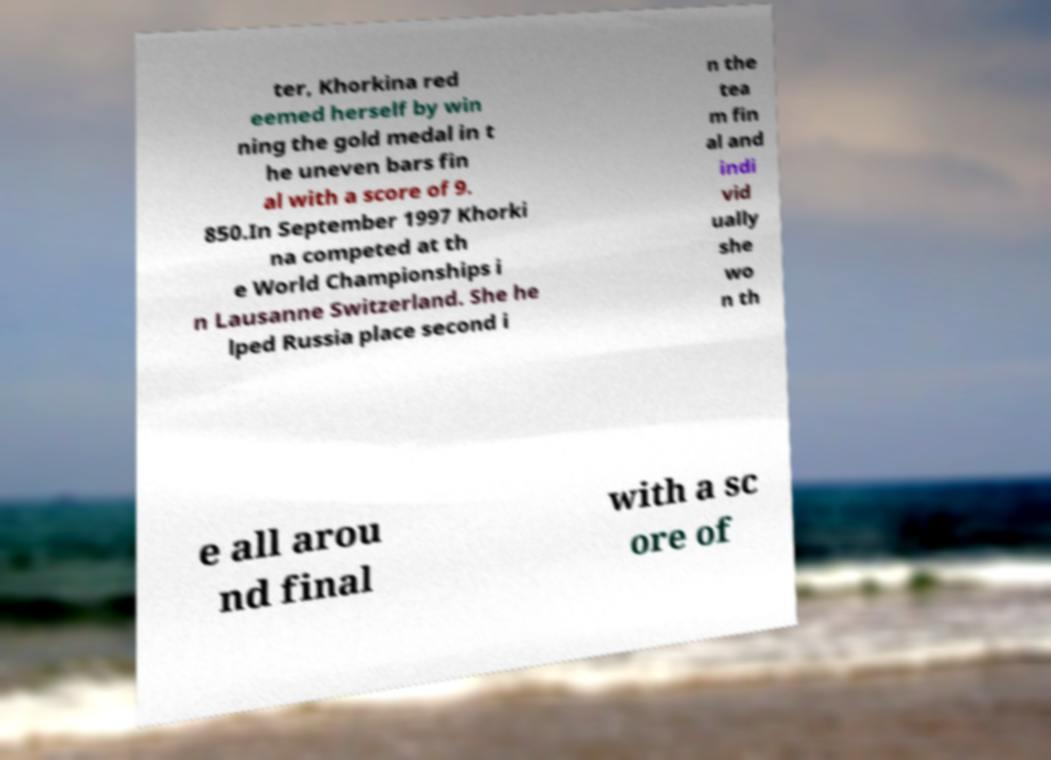What messages or text are displayed in this image? I need them in a readable, typed format. ter, Khorkina red eemed herself by win ning the gold medal in t he uneven bars fin al with a score of 9. 850.In September 1997 Khorki na competed at th e World Championships i n Lausanne Switzerland. She he lped Russia place second i n the tea m fin al and indi vid ually she wo n th e all arou nd final with a sc ore of 